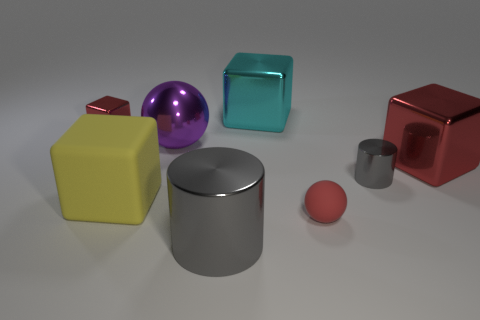Is the number of small red rubber objects that are to the left of the small cube greater than the number of gray metallic things to the right of the purple metallic thing?
Your response must be concise. No. What number of tiny metal cylinders have the same color as the large ball?
Keep it short and to the point. 0. The gray object that is made of the same material as the big cylinder is what size?
Offer a terse response. Small. What number of objects are gray objects in front of the small metal cylinder or brown blocks?
Ensure brevity in your answer.  1. There is a shiny cube that is on the left side of the big purple metal object; is its color the same as the tiny matte thing?
Make the answer very short. Yes. What is the size of the other red metal thing that is the same shape as the large red thing?
Your answer should be compact. Small. There is a cylinder that is to the right of the cube that is behind the tiny metallic object on the left side of the large cyan object; what color is it?
Keep it short and to the point. Gray. Does the big cyan object have the same material as the tiny ball?
Give a very brief answer. No. There is a cylinder that is right of the cylinder in front of the small red rubber thing; is there a shiny thing that is to the left of it?
Ensure brevity in your answer.  Yes. Is the tiny rubber sphere the same color as the small metal block?
Your answer should be compact. Yes. 